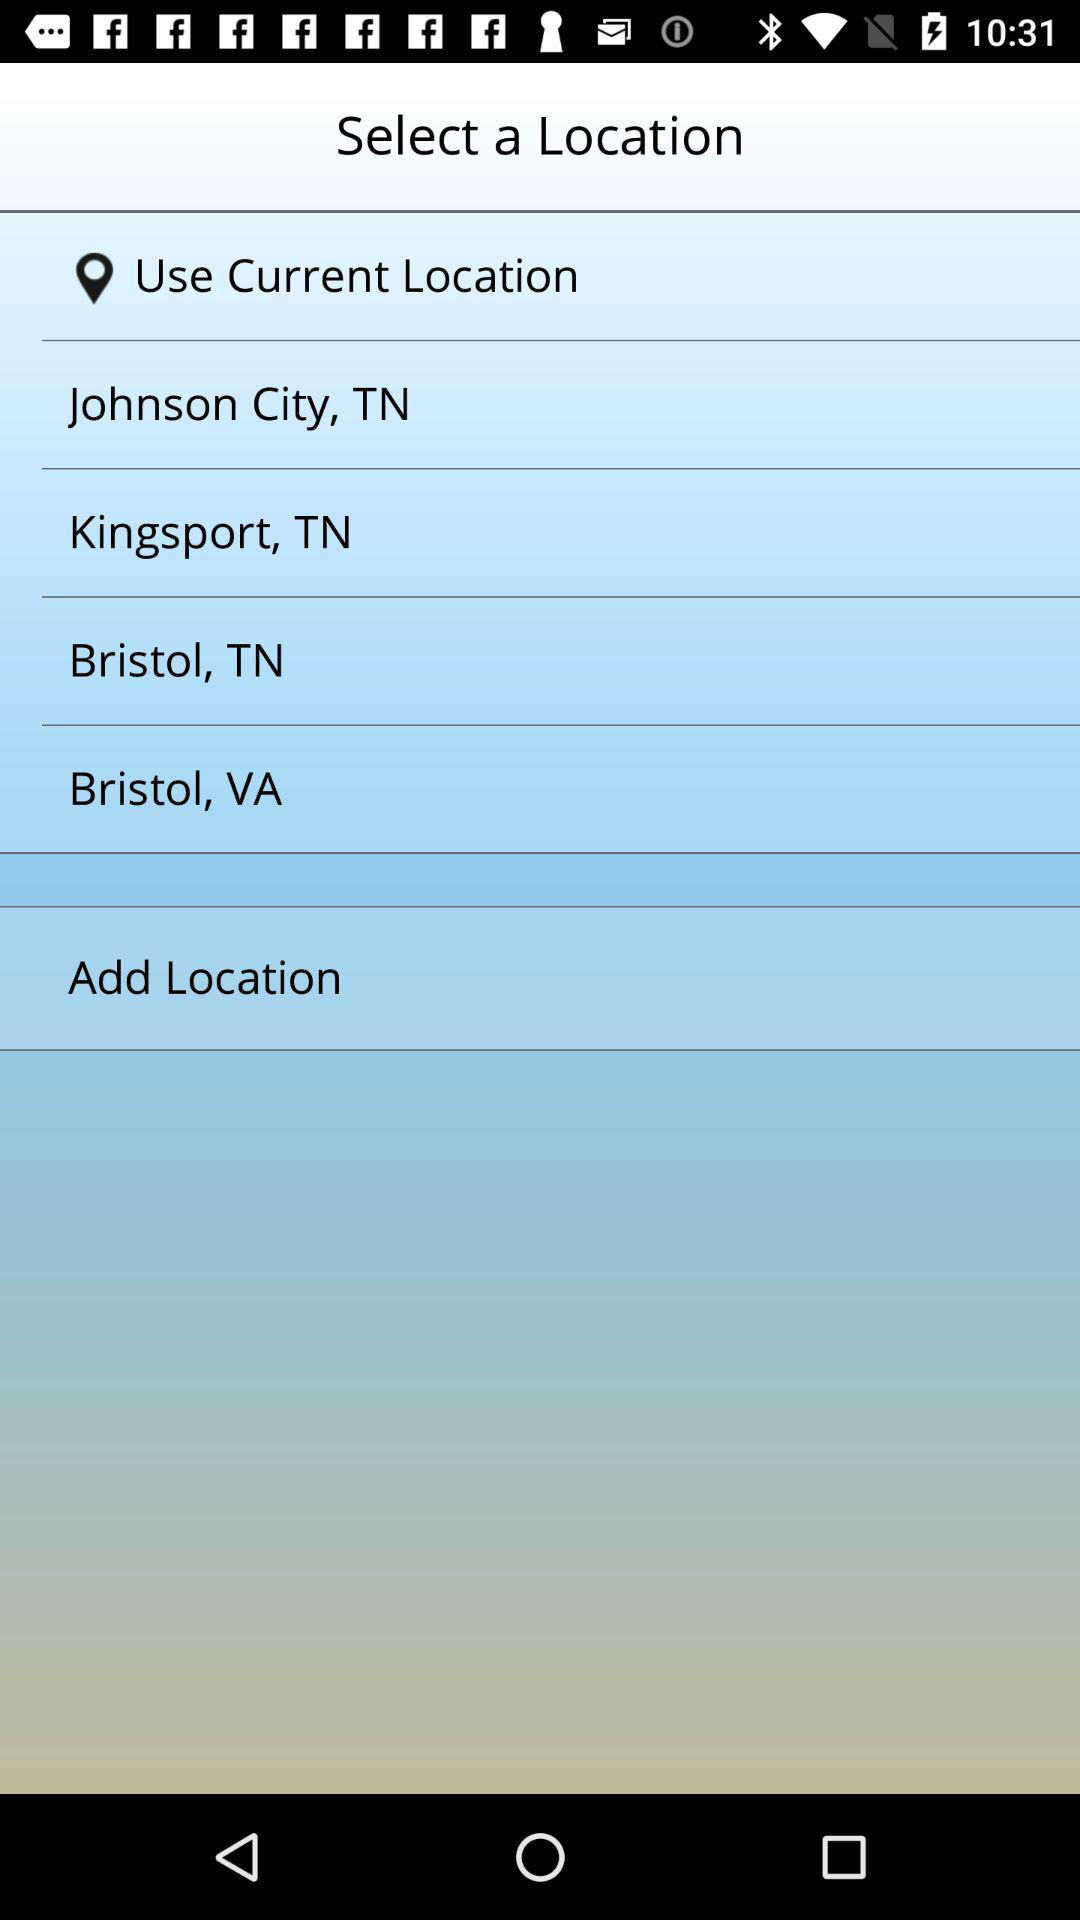What is the mentioned location? The mentioned locations are Johnson City, TN; Kingsport, TN; Bristol, TN and Bristol, VA. 